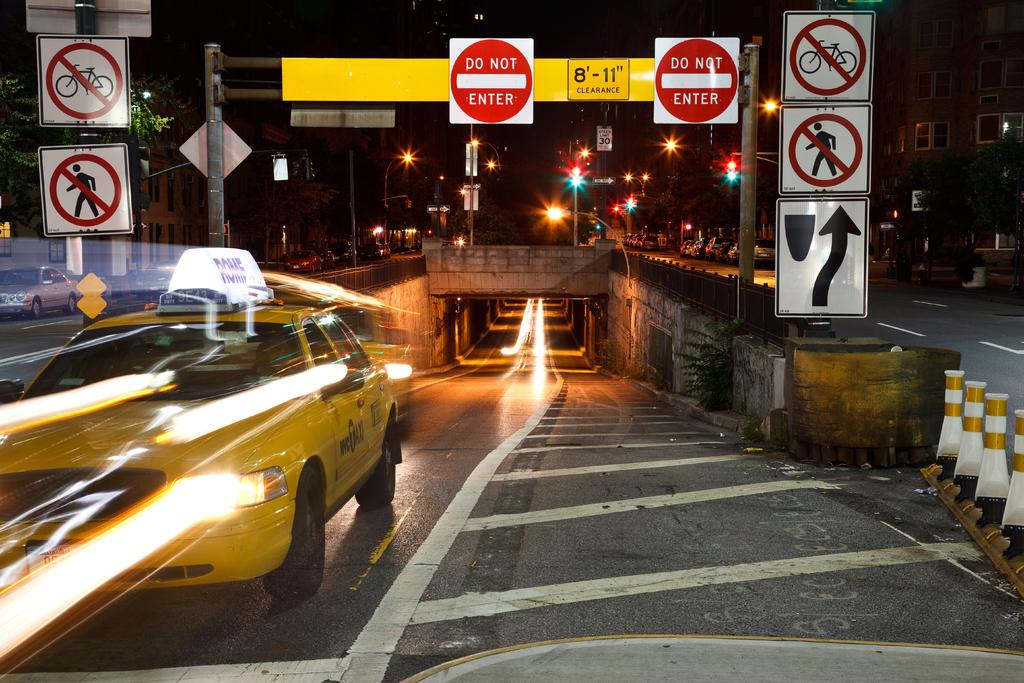<image>
Render a clear and concise summary of the photo. Several Do Not Enter signs are above an underpass. 